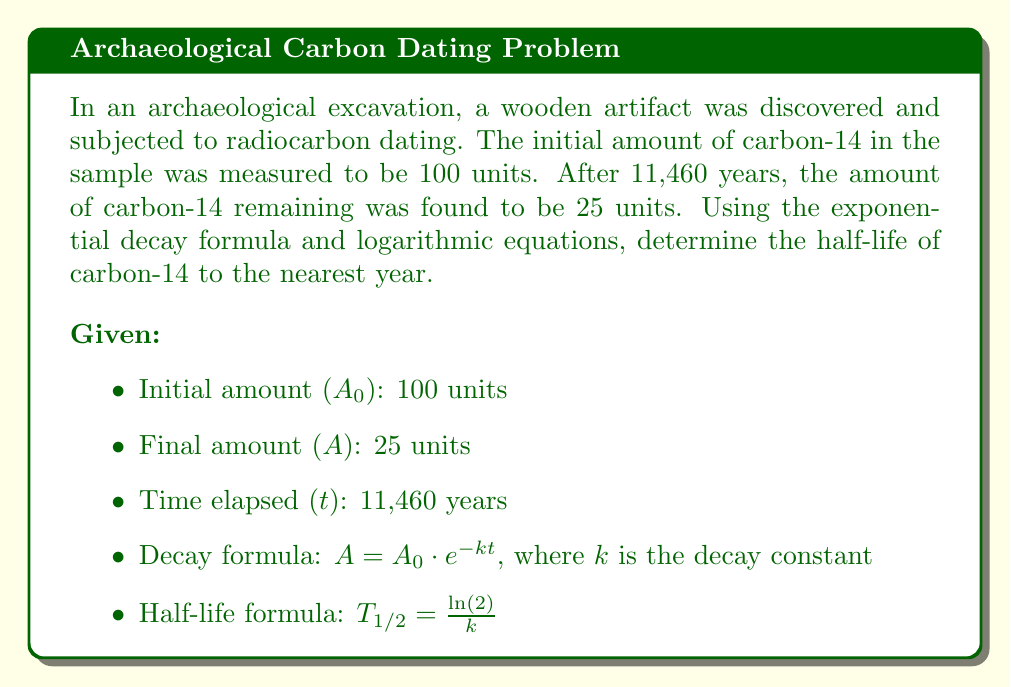Help me with this question. Let's solve this step-by-step:

1) First, we need to find the decay constant $k$ using the exponential decay formula:

   $A = A_0 \cdot e^{-kt}$

2) Substitute the known values:

   $25 = 100 \cdot e^{-k(11460)}$

3) Divide both sides by 100:

   $\frac{1}{4} = e^{-11460k}$

4) Take the natural logarithm of both sides:

   $\ln(\frac{1}{4}) = -11460k$

5) Simplify:

   $-\ln(4) = -11460k$

6) Solve for $k$:

   $k = \frac{\ln(4)}{11460} \approx 0.0000605553$

7) Now that we have $k$, we can use the half-life formula:

   $T_{1/2} = \frac{\ln(2)}{k}$

8) Substitute the value of $k$:

   $T_{1/2} = \frac{\ln(2)}{0.0000605553}$

9) Calculate:

   $T_{1/2} \approx 11449.7$ years

10) Rounding to the nearest year:

    $T_{1/2} \approx 11450$ years
Answer: 11450 years 